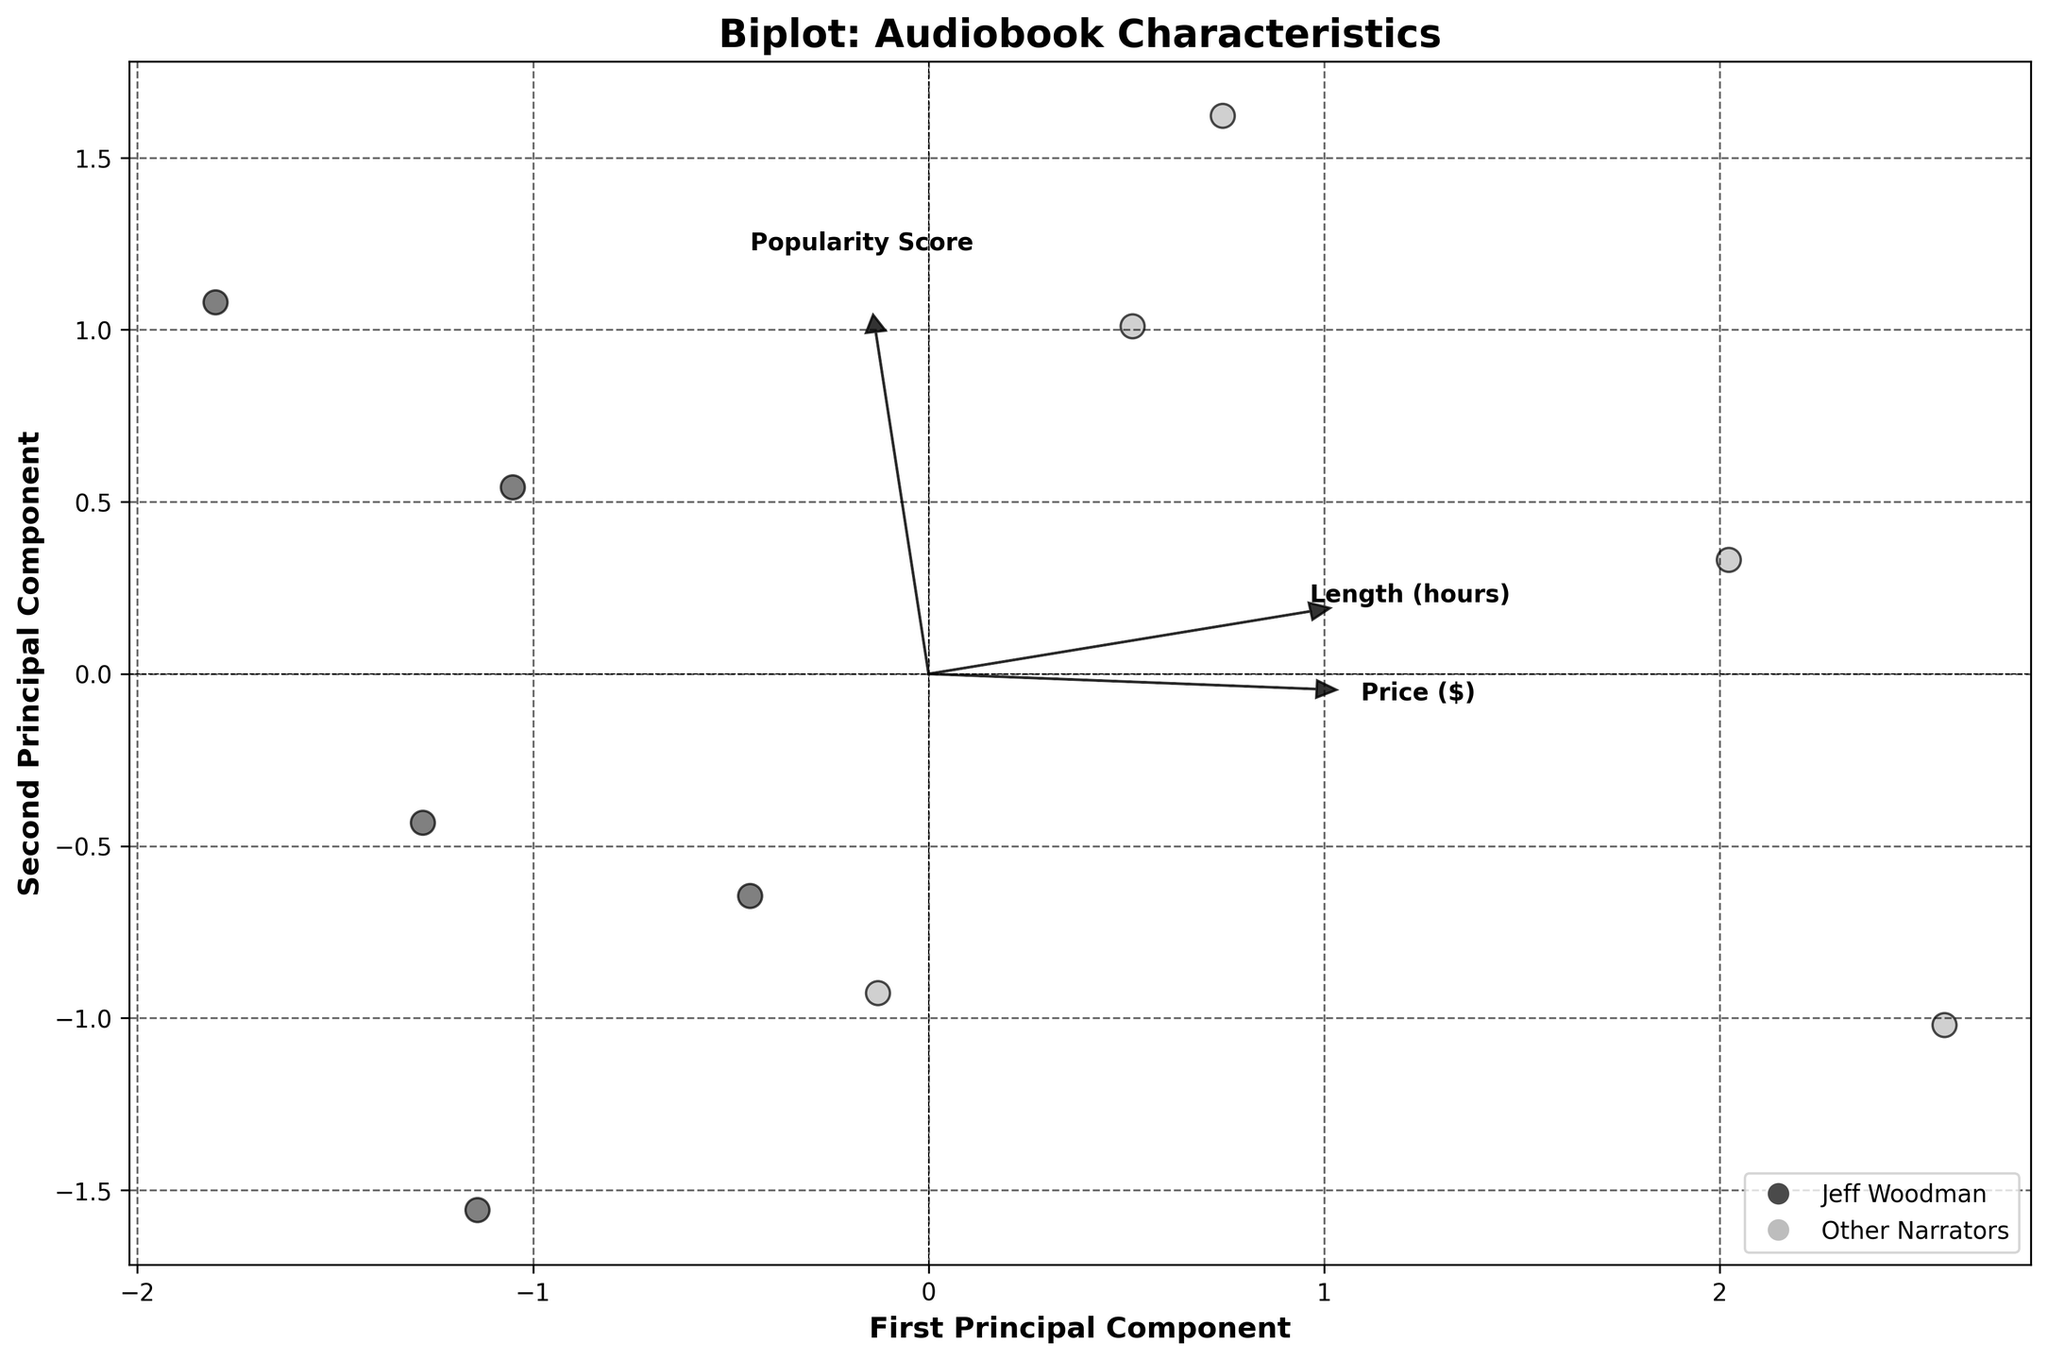How many vectors are there, and what do they represent? There are three vectors on the plot, labeled "Length (hours)," "Price ($)," and "Popularity Score." Each vector represents the correlation of the respective feature with the first two principal components.
Answer: Three vectors representing Length, Price, and Popularity What is the title of the plot? The title is displayed at the top center of the plot and reads "Biplot: Audiobook Characteristics."
Answer: Biplot: Audiobook Characteristics Are audiobooks narrated by Jeff Woodman represented by a specific color? Yes, data points for audiobooks narrated by Jeff Woodman are represented by a dark color, while other narrators' points are a lighter color.
Answer: Dark color for Jeff Woodman Which principal component axis has a length-related arrow pointing more horizontally? The arrow for "Length (hours)" is pointing more horizontally along the first principal component axis (x-axis).
Answer: First Principal Component Which feature has the least correlation with the second principal component? The "Price ($)" vector is closest to the horizontal axis, implying it has the least correlation with the second principal component (y-axis).
Answer: Price ($) How many audiobooks are narrated by Jeff Woodman in the plot? The dark-colored data points represent audiobooks narrated by Jeff Woodman. There are 5 such points.
Answer: Five Do Jeff Woodman's audiobooks tend to be more popular compared to other narrators in the plot? By examining the position of Jeff Woodman's dark-colored points relative to the "Popularity Score" vector, his points are closer in the direction of higher popularity.
Answer: Yes Is the relationship between "Price ($)" and "Popularity Score" strong based on the plot? The vectors for "Price ($)" and "Popularity Score" do not point in closely aligned directions, indicating a weaker relationship between these two features.
Answer: No, it's weak Which audiobook characteristic has the strongest relationship with the second principal component? The "Popularity Score" vector has the largest vertical component, indicating the strongest relationship with the second principal component (y-axis).
Answer: Popularity Score Are there any audiobooks that have both high "Length (hours)" and high "Popularity Score" when comparing narrators? Data points showing a strong response to both vectors would indicate this. Jeff Woodman's and Wil Wheaton's audiobooks (darker and lighter points, respectively) align closely with these vectors' directions.
Answer: Yes 